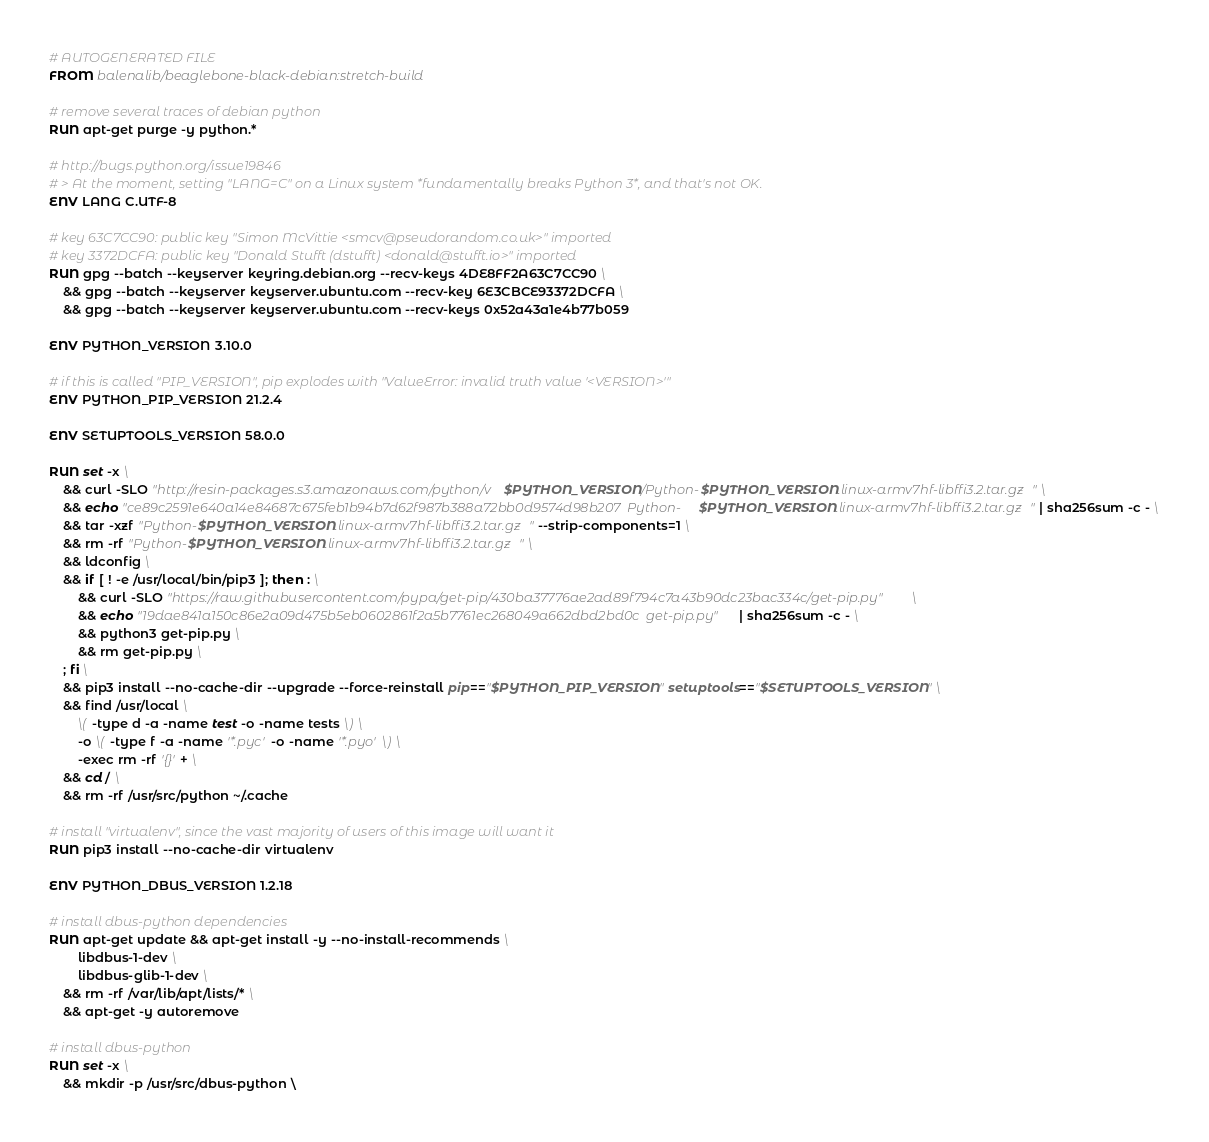<code> <loc_0><loc_0><loc_500><loc_500><_Dockerfile_># AUTOGENERATED FILE
FROM balenalib/beaglebone-black-debian:stretch-build

# remove several traces of debian python
RUN apt-get purge -y python.*

# http://bugs.python.org/issue19846
# > At the moment, setting "LANG=C" on a Linux system *fundamentally breaks Python 3*, and that's not OK.
ENV LANG C.UTF-8

# key 63C7CC90: public key "Simon McVittie <smcv@pseudorandom.co.uk>" imported
# key 3372DCFA: public key "Donald Stufft (dstufft) <donald@stufft.io>" imported
RUN gpg --batch --keyserver keyring.debian.org --recv-keys 4DE8FF2A63C7CC90 \
	&& gpg --batch --keyserver keyserver.ubuntu.com --recv-key 6E3CBCE93372DCFA \
	&& gpg --batch --keyserver keyserver.ubuntu.com --recv-keys 0x52a43a1e4b77b059

ENV PYTHON_VERSION 3.10.0

# if this is called "PIP_VERSION", pip explodes with "ValueError: invalid truth value '<VERSION>'"
ENV PYTHON_PIP_VERSION 21.2.4

ENV SETUPTOOLS_VERSION 58.0.0

RUN set -x \
	&& curl -SLO "http://resin-packages.s3.amazonaws.com/python/v$PYTHON_VERSION/Python-$PYTHON_VERSION.linux-armv7hf-libffi3.2.tar.gz" \
	&& echo "ce89c2591e640a14e84687c675feb1b94b7d62f987b388a72bb0d9574d98b207  Python-$PYTHON_VERSION.linux-armv7hf-libffi3.2.tar.gz" | sha256sum -c - \
	&& tar -xzf "Python-$PYTHON_VERSION.linux-armv7hf-libffi3.2.tar.gz" --strip-components=1 \
	&& rm -rf "Python-$PYTHON_VERSION.linux-armv7hf-libffi3.2.tar.gz" \
	&& ldconfig \
	&& if [ ! -e /usr/local/bin/pip3 ]; then : \
		&& curl -SLO "https://raw.githubusercontent.com/pypa/get-pip/430ba37776ae2ad89f794c7a43b90dc23bac334c/get-pip.py" \
		&& echo "19dae841a150c86e2a09d475b5eb0602861f2a5b7761ec268049a662dbd2bd0c  get-pip.py" | sha256sum -c - \
		&& python3 get-pip.py \
		&& rm get-pip.py \
	; fi \
	&& pip3 install --no-cache-dir --upgrade --force-reinstall pip=="$PYTHON_PIP_VERSION" setuptools=="$SETUPTOOLS_VERSION" \
	&& find /usr/local \
		\( -type d -a -name test -o -name tests \) \
		-o \( -type f -a -name '*.pyc' -o -name '*.pyo' \) \
		-exec rm -rf '{}' + \
	&& cd / \
	&& rm -rf /usr/src/python ~/.cache

# install "virtualenv", since the vast majority of users of this image will want it
RUN pip3 install --no-cache-dir virtualenv

ENV PYTHON_DBUS_VERSION 1.2.18

# install dbus-python dependencies 
RUN apt-get update && apt-get install -y --no-install-recommends \
		libdbus-1-dev \
		libdbus-glib-1-dev \
	&& rm -rf /var/lib/apt/lists/* \
	&& apt-get -y autoremove

# install dbus-python
RUN set -x \
	&& mkdir -p /usr/src/dbus-python \</code> 